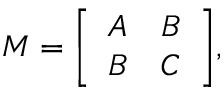<formula> <loc_0><loc_0><loc_500><loc_500>M = { \left [ \begin{array} { l l } { A } & { B } \\ { B } & { C } \end{array} \right ] } ,</formula> 